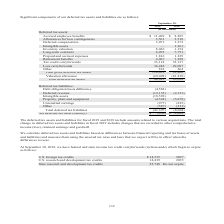According to Cubic's financial document, How are the deferred tax assets and liabilities calculated? based on differences between financial reporting and tax bases of assets and liabilities and measure them using the enacted tax rates and laws that we expect will be in effect when the differences reverse. The document states: "We calculate deferred tax assets and liabilities based on differences between financial reporting and tax bases of assets and liabilities and measure ..." Also, What does the total change in deferred tax assets and liabilities in 2019 include? changes that are recorded to other comprehensive income (loss), retained earnings and goodwill. The document states: "ax assets and liabilities in fiscal 2019 includes changes that are recorded to other comprehensive income (loss), retained earnings and goodwill. We c..." Also, What are the items under deferred tax liabilities? The document contains multiple relevant values: Debt obligation basis difference, Deferred revenue, Intangible assets, Property, plant and equipment, Unremitted earnings, Other. From the document: "Deferred tax liabilities: Debt obligation basis difference (4,582) — Intangible assets — 1,361 Inventory valuation 8,036 1,154 Property, plant and equ..." Also, How many items are there under deferred tax liabilities? Counting the relevant items in the document: Debt obligation basis difference, Deferred revenue, Intangible assets, Property, plant and equipment, Unremitted earnings, Other, I find 6 instances. The key data points involved are: Debt obligation basis difference, Deferred revenue, Intangible assets. Also, can you calculate: What is the change in the amount of prepaid and accrued expenses from 2018 to 2019? Based on the calculation: 1,816-1,229, the result is 587 (in thousands). This is based on the information: "ontracts 6,995 7,751 Prepaid and accrued expenses 1,816 1,229 ts 6,995 7,751 Prepaid and accrued expenses 1,816 1,229..." The key data points involved are: 1,229, 1,816. Also, can you calculate: What is the percentage change in the amount of prepaid and accrued expenses from 2018 to 2019? To answer this question, I need to perform calculations using the financial data. The calculation is: (1,816-1,229)/1,229, which equals 47.76 (percentage). This is based on the information: "ontracts 6,995 7,751 Prepaid and accrued expenses 1,816 1,229 ts 6,995 7,751 Prepaid and accrued expenses 1,816 1,229..." The key data points involved are: 1,229, 1,816. 